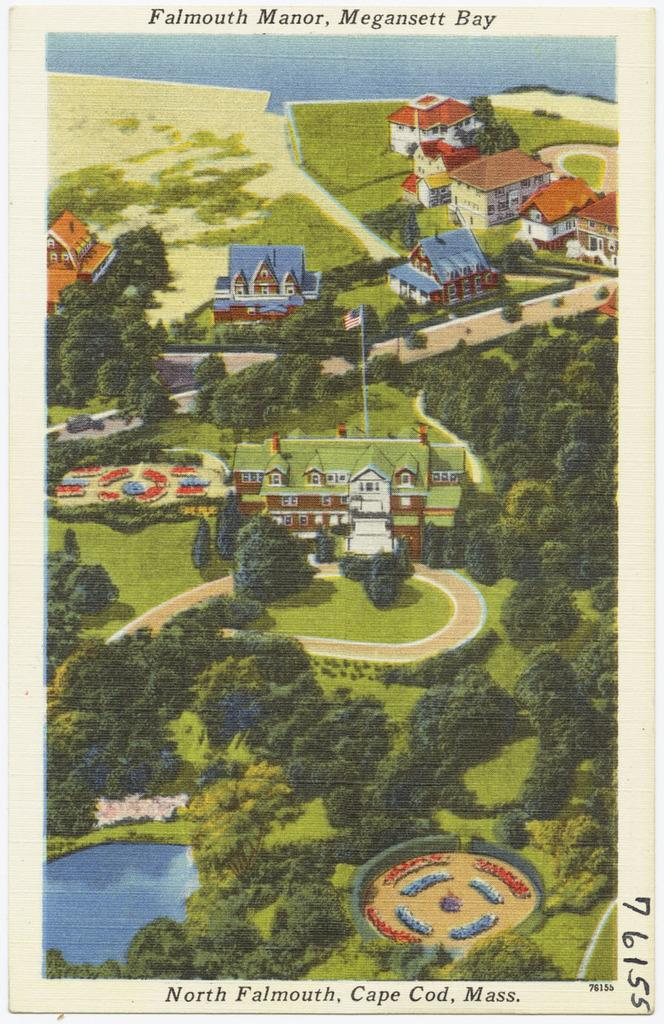<image>
Create a compact narrative representing the image presented. Someone has handwritten the number 76155 on the side of this postcard. 